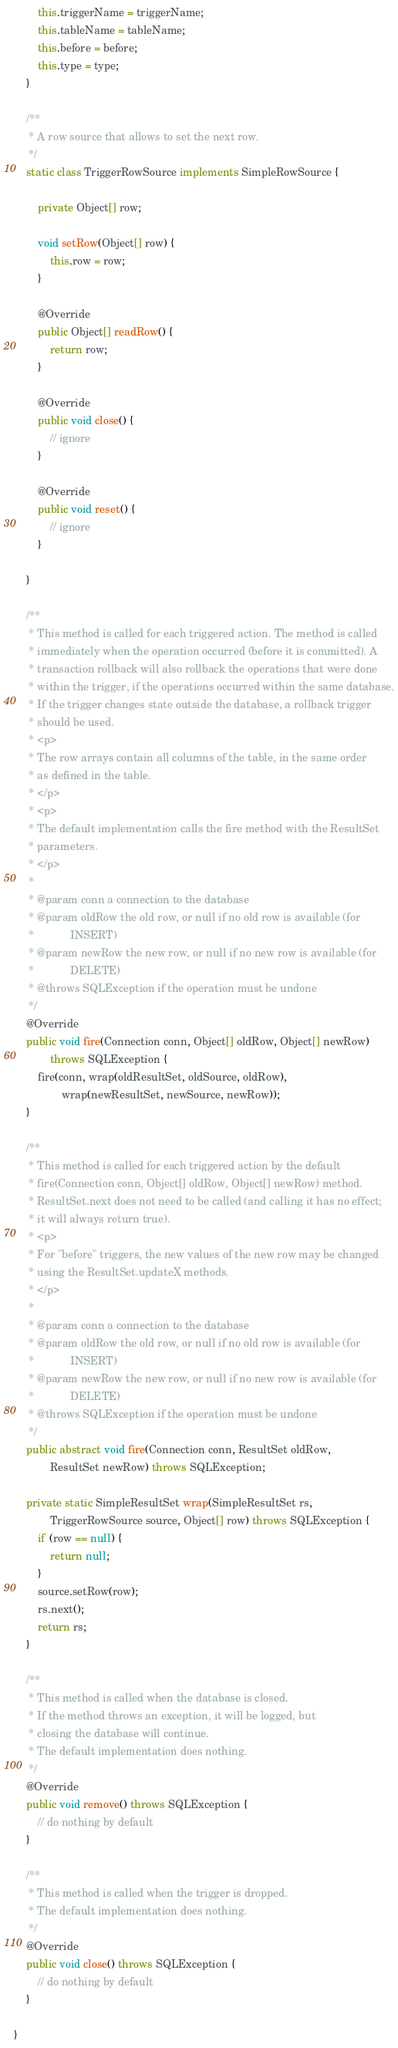Convert code to text. <code><loc_0><loc_0><loc_500><loc_500><_Java_>        this.triggerName = triggerName;
        this.tableName = tableName;
        this.before = before;
        this.type = type;
    }

    /**
     * A row source that allows to set the next row.
     */
    static class TriggerRowSource implements SimpleRowSource {

        private Object[] row;

        void setRow(Object[] row) {
            this.row = row;
        }

        @Override
        public Object[] readRow() {
            return row;
        }

        @Override
        public void close() {
            // ignore
        }

        @Override
        public void reset() {
            // ignore
        }

    }

    /**
     * This method is called for each triggered action. The method is called
     * immediately when the operation occurred (before it is committed). A
     * transaction rollback will also rollback the operations that were done
     * within the trigger, if the operations occurred within the same database.
     * If the trigger changes state outside the database, a rollback trigger
     * should be used.
     * <p>
     * The row arrays contain all columns of the table, in the same order
     * as defined in the table.
     * </p>
     * <p>
     * The default implementation calls the fire method with the ResultSet
     * parameters.
     * </p>
     *
     * @param conn a connection to the database
     * @param oldRow the old row, or null if no old row is available (for
     *            INSERT)
     * @param newRow the new row, or null if no new row is available (for
     *            DELETE)
     * @throws SQLException if the operation must be undone
     */
    @Override
    public void fire(Connection conn, Object[] oldRow, Object[] newRow)
            throws SQLException {
        fire(conn, wrap(oldResultSet, oldSource, oldRow),
                wrap(newResultSet, newSource, newRow));
    }

    /**
     * This method is called for each triggered action by the default
     * fire(Connection conn, Object[] oldRow, Object[] newRow) method.
     * ResultSet.next does not need to be called (and calling it has no effect;
     * it will always return true).
     * <p>
     * For "before" triggers, the new values of the new row may be changed
     * using the ResultSet.updateX methods.
     * </p>
     *
     * @param conn a connection to the database
     * @param oldRow the old row, or null if no old row is available (for
     *            INSERT)
     * @param newRow the new row, or null if no new row is available (for
     *            DELETE)
     * @throws SQLException if the operation must be undone
     */
    public abstract void fire(Connection conn, ResultSet oldRow,
            ResultSet newRow) throws SQLException;

    private static SimpleResultSet wrap(SimpleResultSet rs,
            TriggerRowSource source, Object[] row) throws SQLException {
        if (row == null) {
            return null;
        }
        source.setRow(row);
        rs.next();
        return rs;
    }

    /**
     * This method is called when the database is closed.
     * If the method throws an exception, it will be logged, but
     * closing the database will continue.
     * The default implementation does nothing.
     */
    @Override
    public void remove() throws SQLException {
        // do nothing by default
    }

    /**
     * This method is called when the trigger is dropped.
     * The default implementation does nothing.
     */
    @Override
    public void close() throws SQLException {
        // do nothing by default
    }

}
</code> 